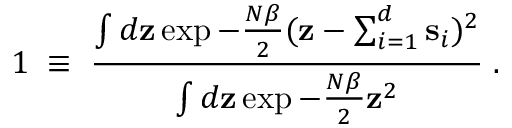Convert formula to latex. <formula><loc_0><loc_0><loc_500><loc_500>1 \, \equiv \, { \frac { \int d { z } \exp - { \frac { N \beta } { 2 } } ( { z } - \sum _ { i = 1 } ^ { d } { s } _ { i } ) ^ { 2 } } { \int d { z } \exp - { \frac { N \beta } { 2 } } { z } ^ { 2 } } } \, .</formula> 